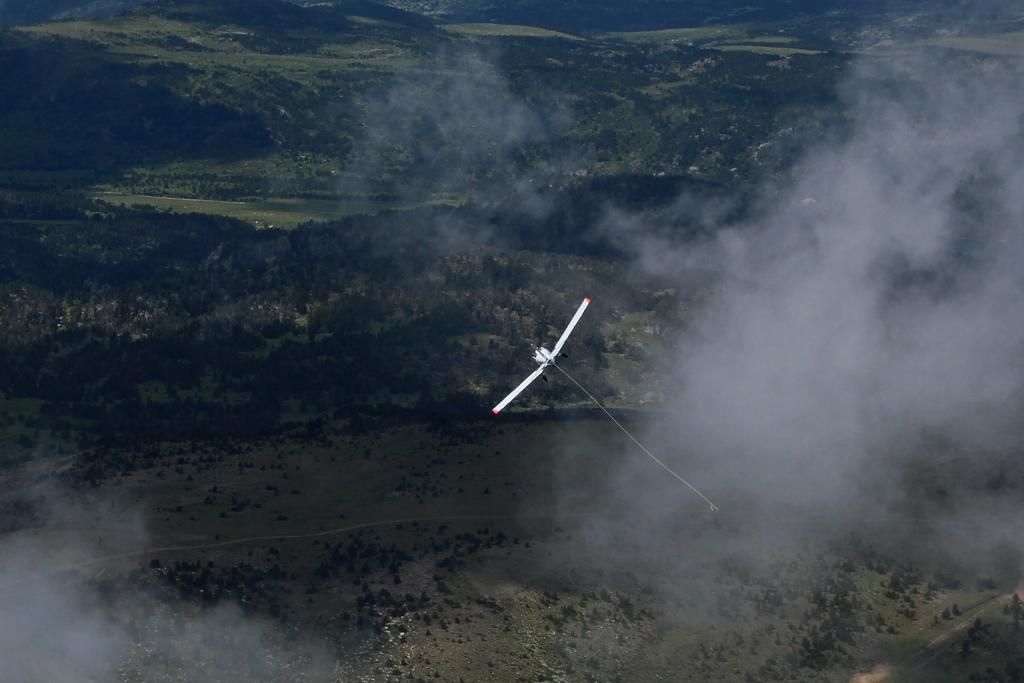What type of aircraft is in the sky in the image? There is a motor glider in the sky in the image. What can be seen in the sky besides the motor glider? There are clouds visible in the image. What type of natural feature is present in the image? There is a group of trees visible in the image. What type of landscape can be seen in the image? There are hills visible in the image. What type of grass is growing on the motor glider in the image? There is no grass growing on the motor glider in the image; it is an aircraft flying in the sky. 